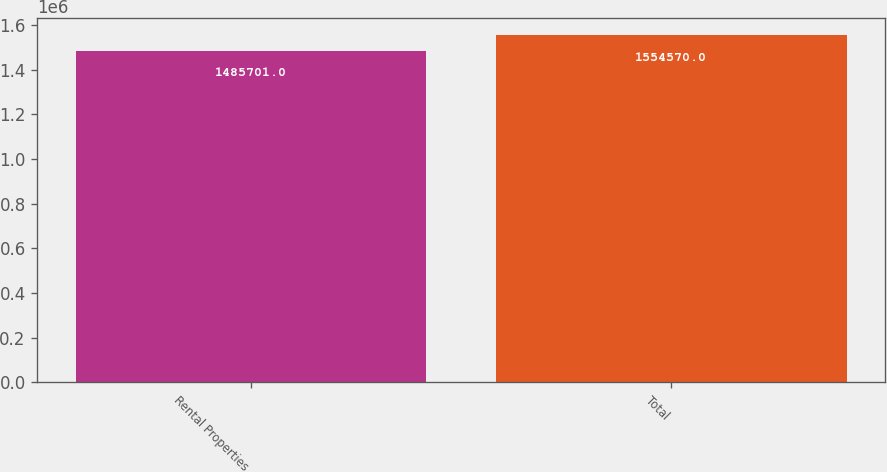<chart> <loc_0><loc_0><loc_500><loc_500><bar_chart><fcel>Rental Properties<fcel>Total<nl><fcel>1.4857e+06<fcel>1.55457e+06<nl></chart> 